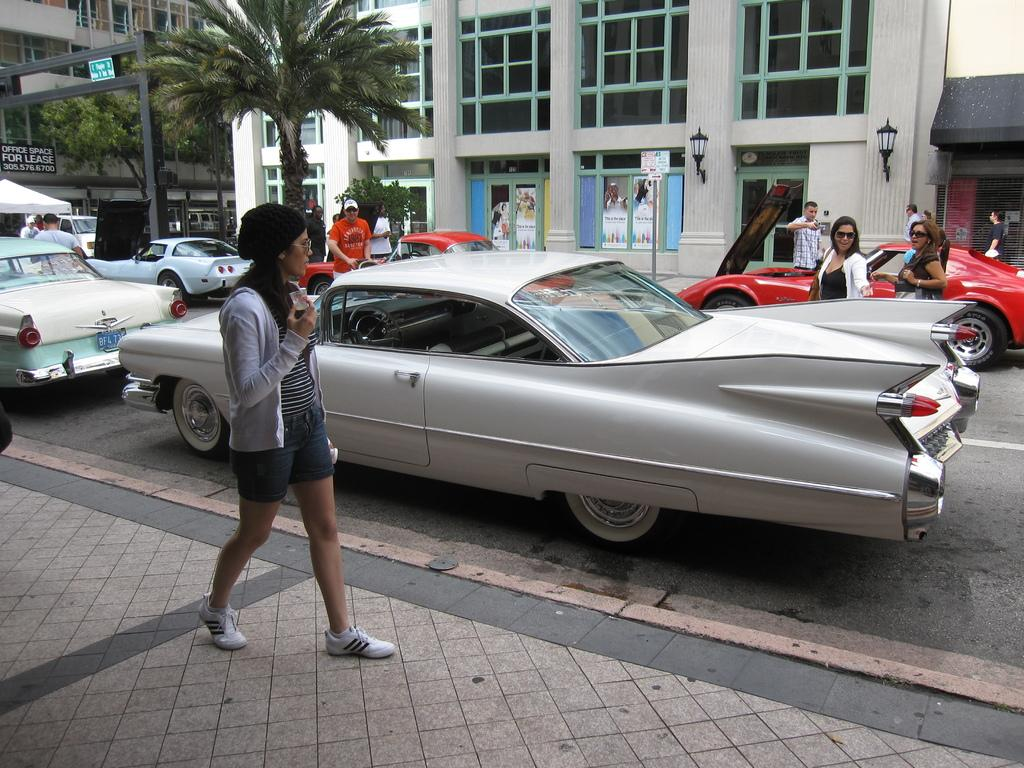What can be seen in the background of the image? There are buildings, people, and trees in the background of the image. What is happening on the road in the image? Vehicles are visible on the road in the image. Can you describe the person on the left side of the image? There is a person walking on the left side of the image. What type of plastic is covering the trees in the image? There is no plastic covering the trees in the image; the trees are visible in their natural state. Can you see any steam coming from the vehicles in the image? There is no mention of steam in the image, and it cannot be determined from the provided facts. 